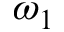Convert formula to latex. <formula><loc_0><loc_0><loc_500><loc_500>\omega _ { 1 }</formula> 